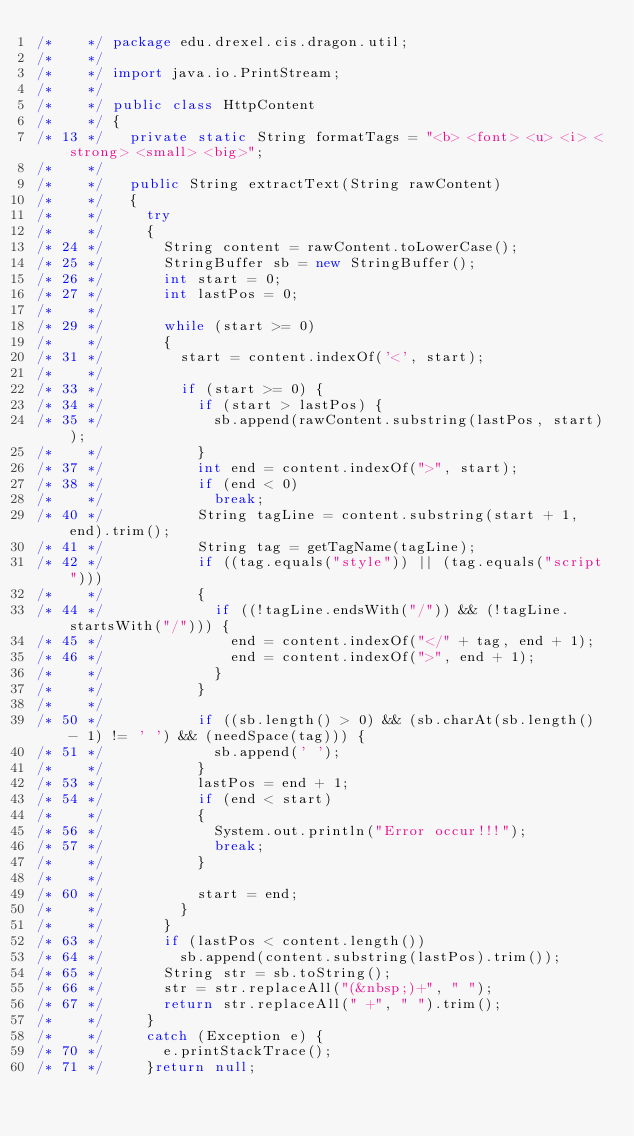Convert code to text. <code><loc_0><loc_0><loc_500><loc_500><_Java_>/*    */ package edu.drexel.cis.dragon.util;
/*    */ 
/*    */ import java.io.PrintStream;
/*    */ 
/*    */ public class HttpContent
/*    */ {
/* 13 */   private static String formatTags = "<b> <font> <u> <i> <strong> <small> <big>";
/*    */ 
/*    */   public String extractText(String rawContent)
/*    */   {
/*    */     try
/*    */     {
/* 24 */       String content = rawContent.toLowerCase();
/* 25 */       StringBuffer sb = new StringBuffer();
/* 26 */       int start = 0;
/* 27 */       int lastPos = 0;
/*    */ 
/* 29 */       while (start >= 0)
/*    */       {
/* 31 */         start = content.indexOf('<', start);
/*    */ 
/* 33 */         if (start >= 0) {
/* 34 */           if (start > lastPos) {
/* 35 */             sb.append(rawContent.substring(lastPos, start));
/*    */           }
/* 37 */           int end = content.indexOf(">", start);
/* 38 */           if (end < 0)
/*    */             break;
/* 40 */           String tagLine = content.substring(start + 1, end).trim();
/* 41 */           String tag = getTagName(tagLine);
/* 42 */           if ((tag.equals("style")) || (tag.equals("script")))
/*    */           {
/* 44 */             if ((!tagLine.endsWith("/")) && (!tagLine.startsWith("/"))) {
/* 45 */               end = content.indexOf("</" + tag, end + 1);
/* 46 */               end = content.indexOf(">", end + 1);
/*    */             }
/*    */           }
/*    */ 
/* 50 */           if ((sb.length() > 0) && (sb.charAt(sb.length() - 1) != ' ') && (needSpace(tag))) {
/* 51 */             sb.append(' ');
/*    */           }
/* 53 */           lastPos = end + 1;
/* 54 */           if (end < start)
/*    */           {
/* 56 */             System.out.println("Error occur!!!");
/* 57 */             break;
/*    */           }
/*    */ 
/* 60 */           start = end;
/*    */         }
/*    */       }
/* 63 */       if (lastPos < content.length())
/* 64 */         sb.append(content.substring(lastPos).trim());
/* 65 */       String str = sb.toString();
/* 66 */       str = str.replaceAll("(&nbsp;)+", " ");
/* 67 */       return str.replaceAll(" +", " ").trim();
/*    */     }
/*    */     catch (Exception e) {
/* 70 */       e.printStackTrace();
/* 71 */     }return null;</code> 